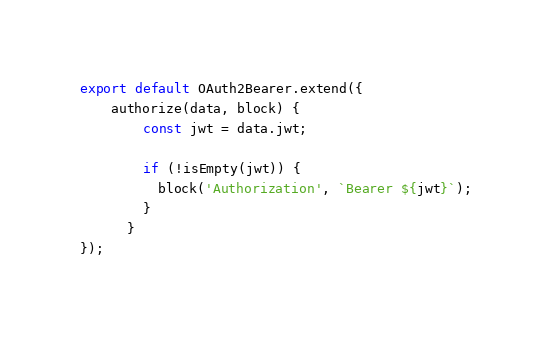<code> <loc_0><loc_0><loc_500><loc_500><_JavaScript_>export default OAuth2Bearer.extend({
    authorize(data, block) {
        const jwt = data.jwt;
    
        if (!isEmpty(jwt)) {
          block('Authorization', `Bearer ${jwt}`);
        }
      }
});</code> 